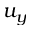<formula> <loc_0><loc_0><loc_500><loc_500>u _ { y }</formula> 